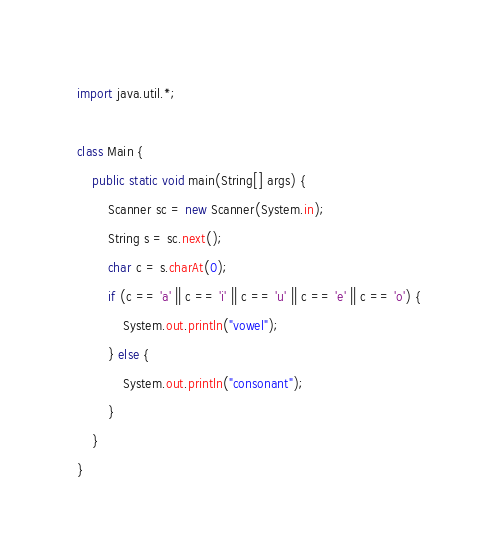Convert code to text. <code><loc_0><loc_0><loc_500><loc_500><_Java_>import java.util.*;

class Main {
    public static void main(String[] args) {
        Scanner sc = new Scanner(System.in);
        String s = sc.next();
        char c = s.charAt(0);
        if (c == 'a' || c == 'i' || c == 'u' || c == 'e' || c == 'o') {
            System.out.println("vowel");
        } else {
            System.out.println("consonant");
        }
    }
}</code> 